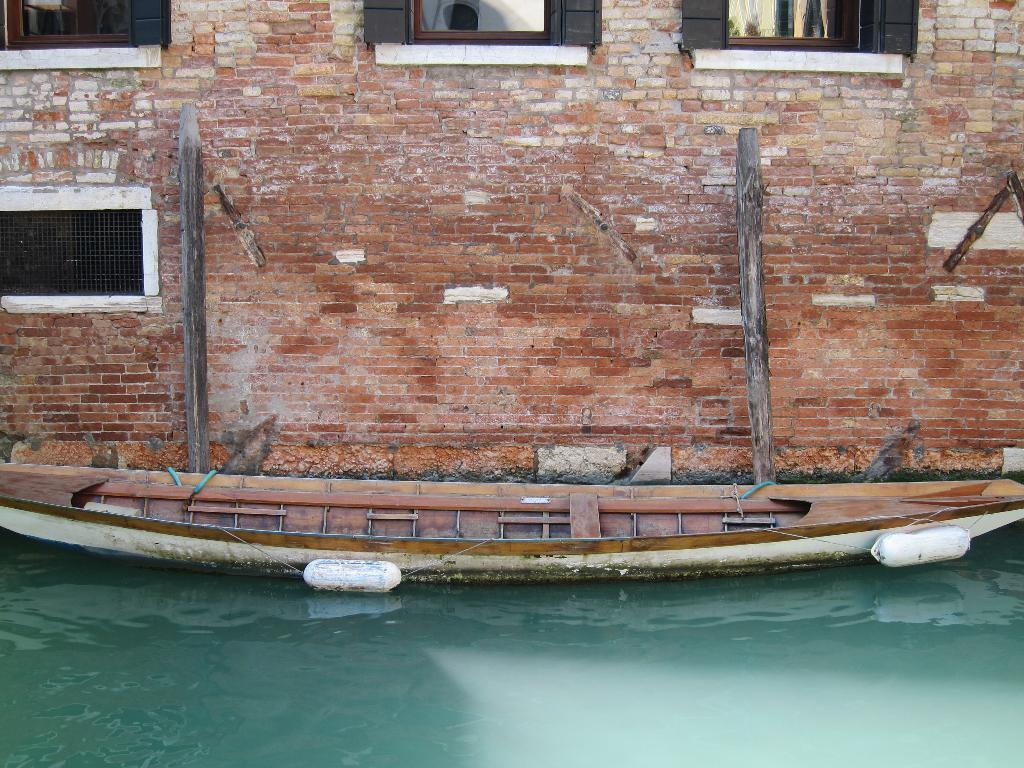What is the main subject of the image? The main subject of the image is a boat. Where is the boat located? The boat is on water. What other objects can be seen in the image? There are wooden poles and a brick wall visible in the image. What can be seen in the background of the image? There are windows visible in the background of the image. What type of vest is being worn by the butter in the image? There is no vest or butter present in the image. What month is depicted in the image? The image does not depict a specific month; it features a boat on water with wooden poles, a brick wall, and windows in the background. 